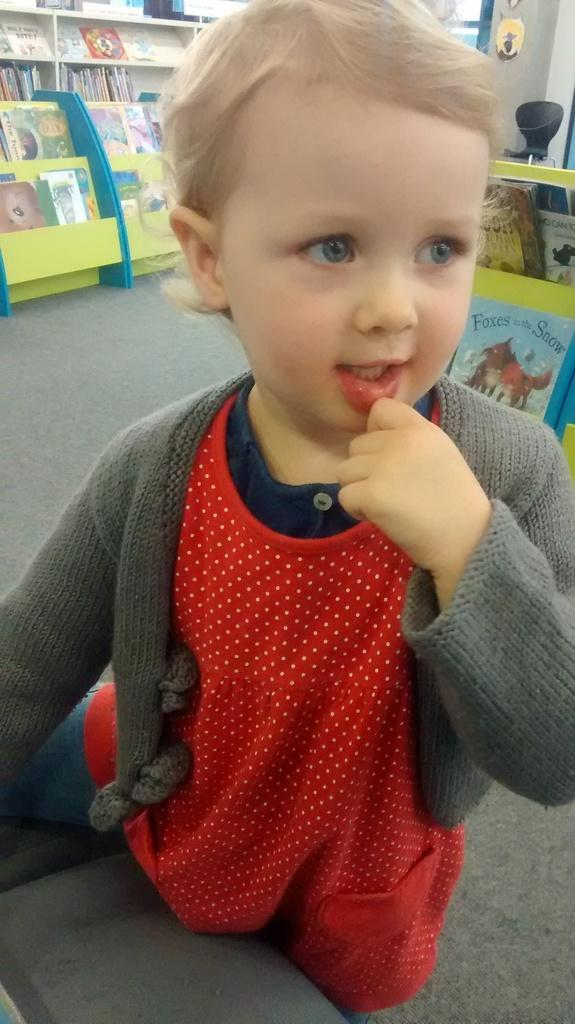What is the main subject of the image? There is a small baby boy in the image. What is the baby boy doing in the image? The baby boy is standing. What else can be seen in the image besides the baby boy? There are shelves with books in the image. What letter is written on the wall behind the baby boy? There is no letter written on the wall behind the baby boy in the image. 